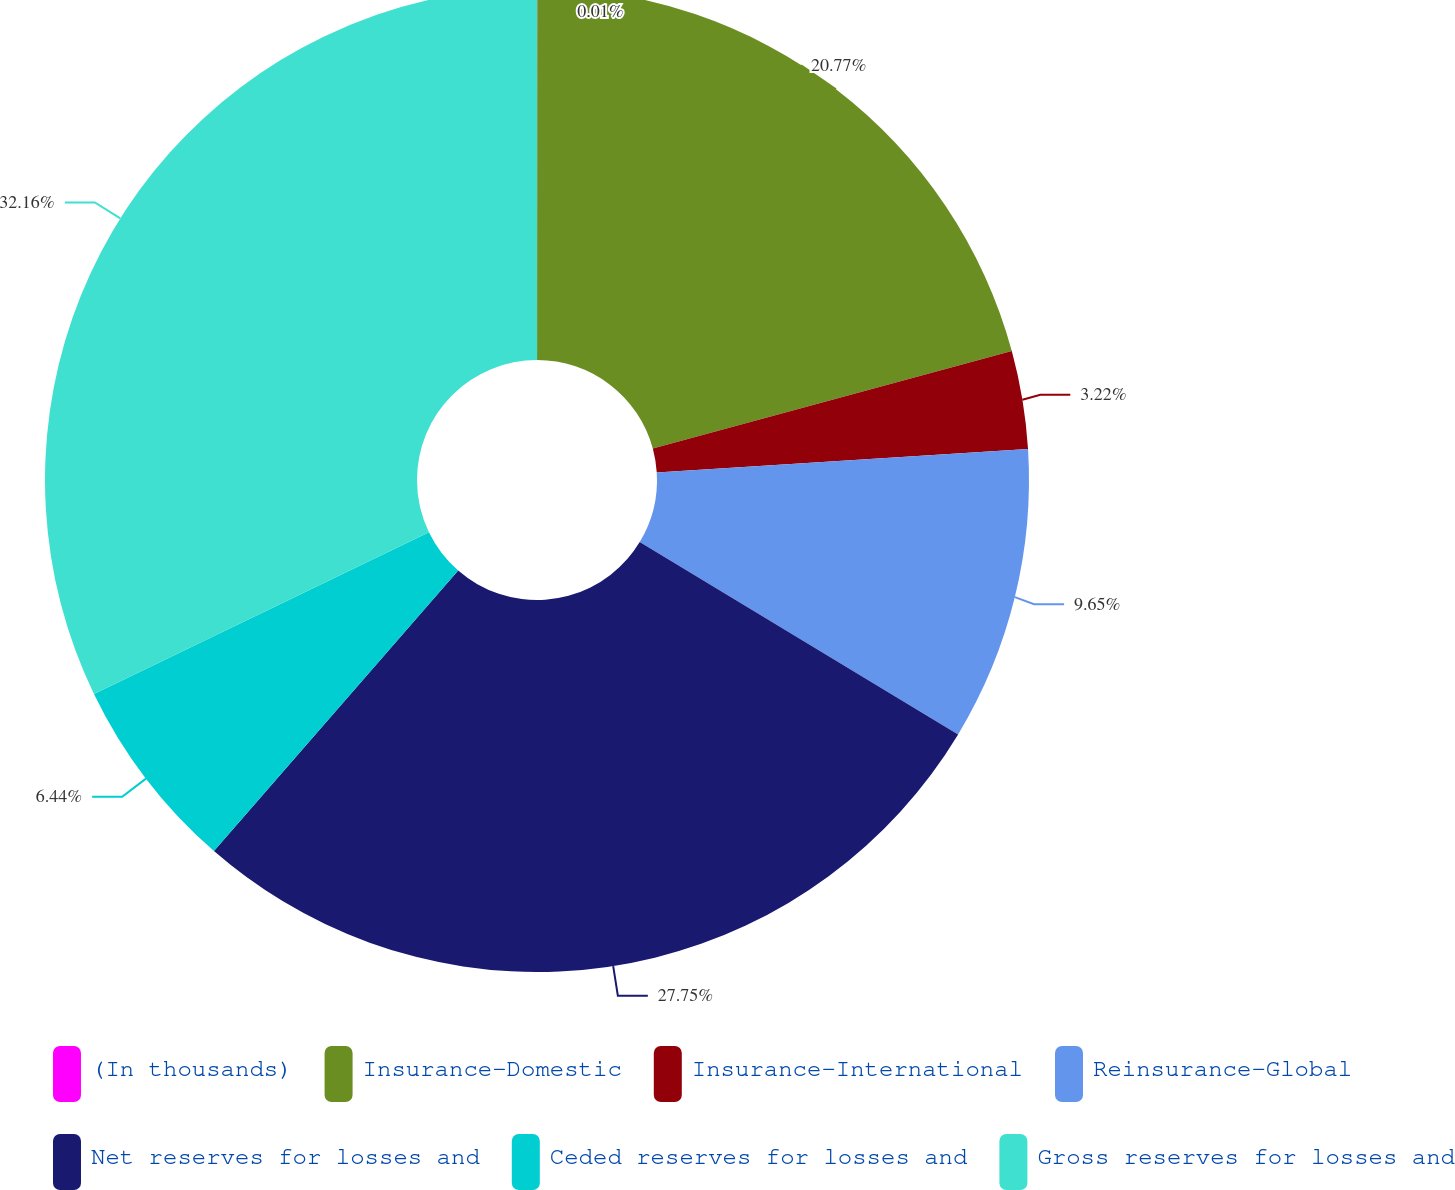Convert chart. <chart><loc_0><loc_0><loc_500><loc_500><pie_chart><fcel>(In thousands)<fcel>Insurance-Domestic<fcel>Insurance-International<fcel>Reinsurance-Global<fcel>Net reserves for losses and<fcel>Ceded reserves for losses and<fcel>Gross reserves for losses and<nl><fcel>0.01%<fcel>20.77%<fcel>3.22%<fcel>9.65%<fcel>27.75%<fcel>6.44%<fcel>32.16%<nl></chart> 